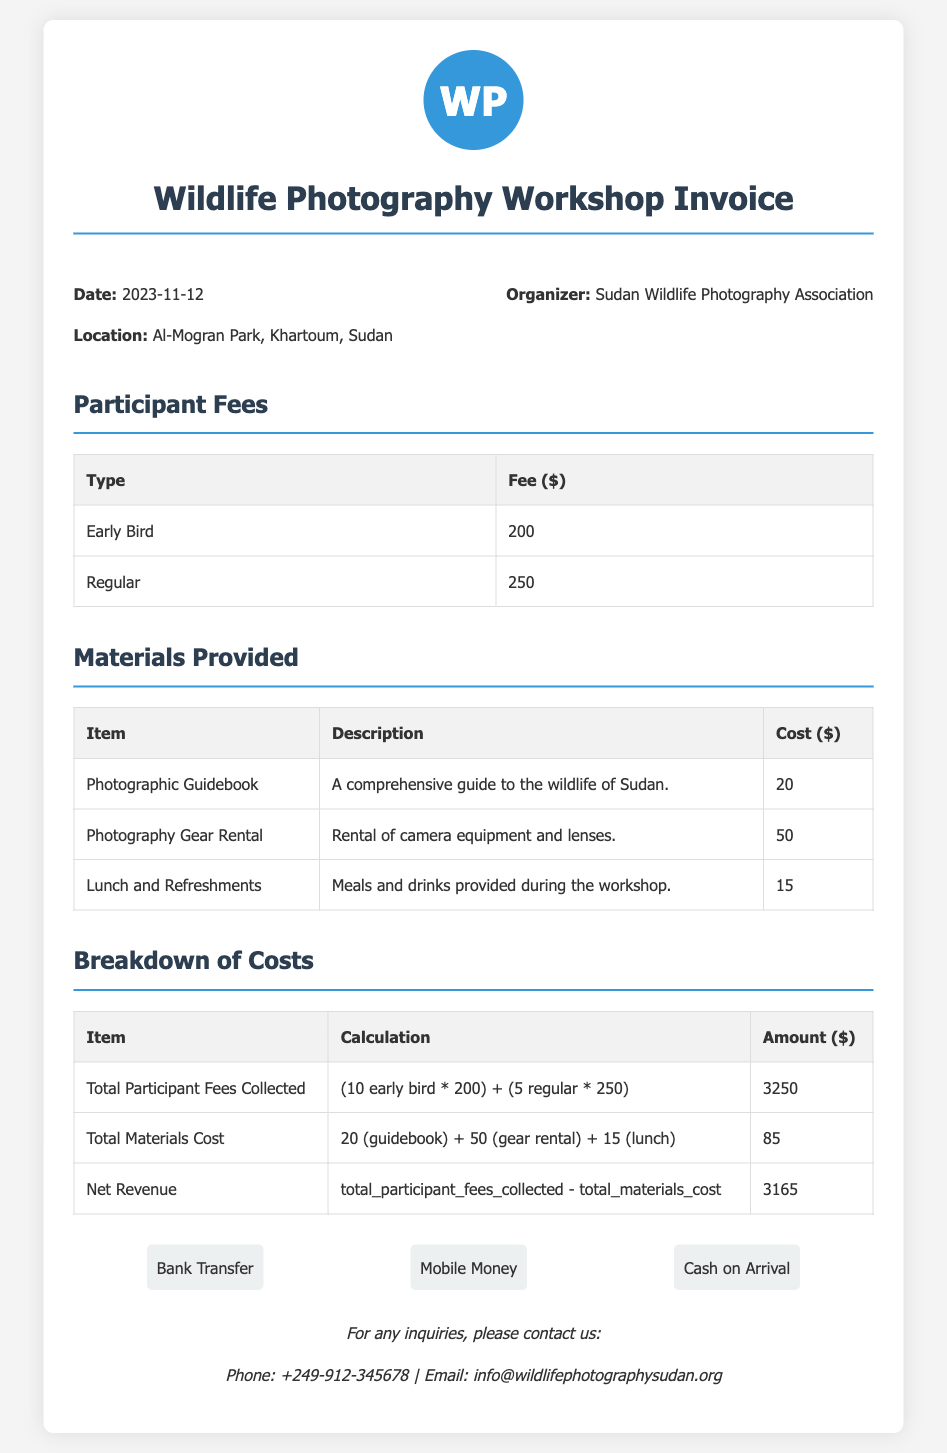What is the date of the workshop? The date is specified in the document under the information section.
Answer: 2023-11-12 Where is the workshop located? The location is mentioned as Al-Mogran Park in Khartoum, Sudan.
Answer: Al-Mogran Park, Khartoum, Sudan What is the fee for early bird participants? The fee for early bird participants is listed in the participant fees section.
Answer: 200 How many regular participants are there? The number of regular participants can be inferred from the total fees collected breakdown.
Answer: 5 What is the total amount collected from participant fees? The total participant fees collected is given in the breakdown of costs section.
Answer: 3250 What is included in the materials provided? The materials items and descriptions are listed under the materials provided section.
Answer: Photographic Guidebook, Photography Gear Rental, Lunch and Refreshments What is the cost of the Photography Gear Rental? The cost of this particular material is provided in the materials section.
Answer: 50 What is the net revenue from the workshop? The net revenue is calculated from the breakdown of costs provided in the document.
Answer: 3165 Which organization is hosting the workshop? The hosting organization is mentioned in the information section.
Answer: Sudan Wildlife Photography Association 